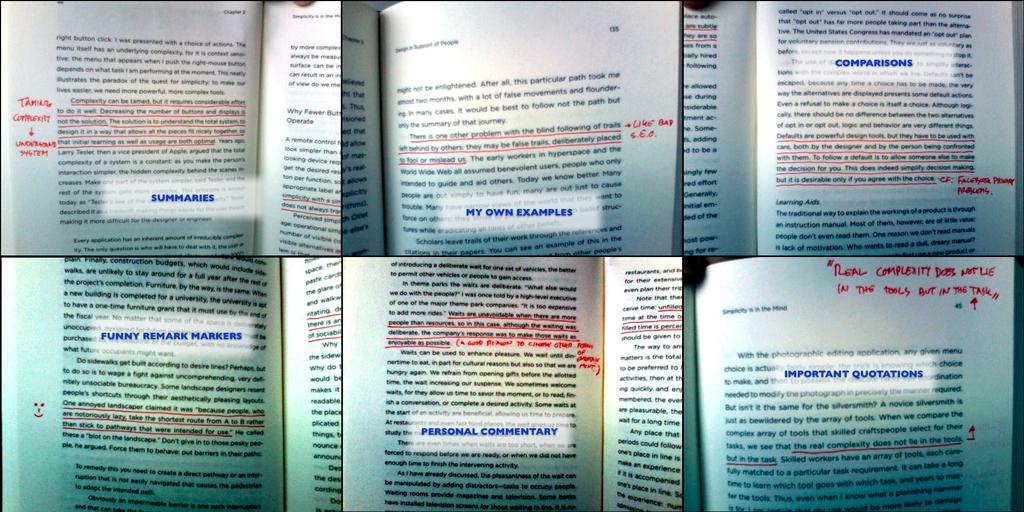What is the top left section called?
Make the answer very short. Summaries. 